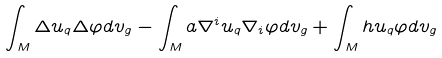Convert formula to latex. <formula><loc_0><loc_0><loc_500><loc_500>\int _ { M } \Delta u _ { q } \Delta \varphi d v _ { g } - \int _ { M } a \nabla ^ { i } u _ { q } \nabla _ { i } \varphi d v _ { g } + \int _ { M } h u _ { q } \varphi d v _ { g }</formula> 